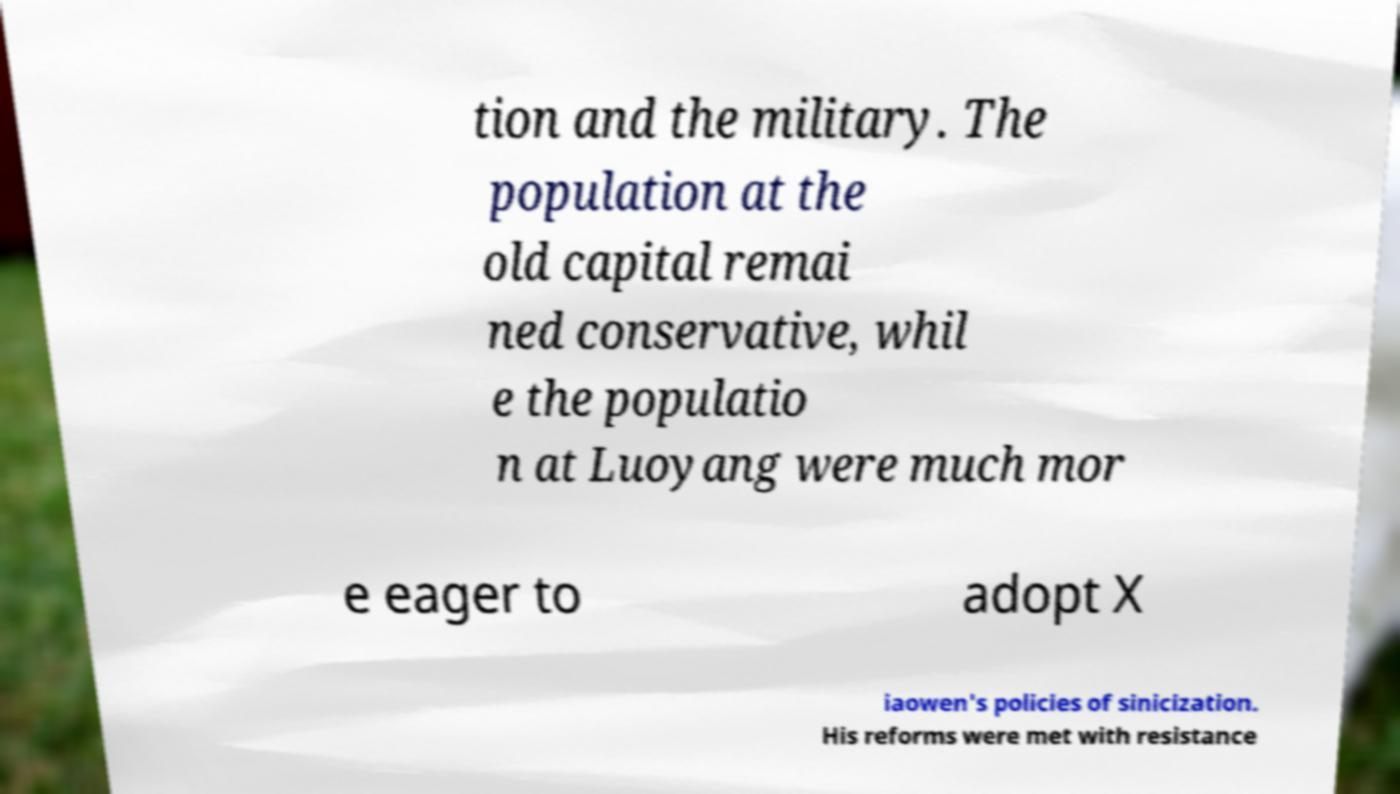Could you assist in decoding the text presented in this image and type it out clearly? tion and the military. The population at the old capital remai ned conservative, whil e the populatio n at Luoyang were much mor e eager to adopt X iaowen's policies of sinicization. His reforms were met with resistance 